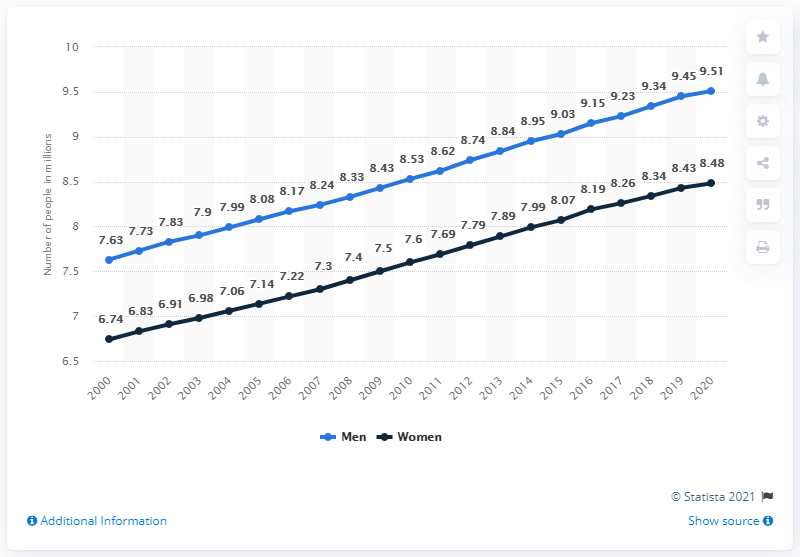Point out several critical features in this image. In 2020, there were approximately 8.48 million single females living in Canada. In the year 2020, there were more single males in Canada than women. In 2020, there were approximately 9.51 million single males in Canada. Since the year 2000, the number of single males and females in Canada has been increasing steadily. 